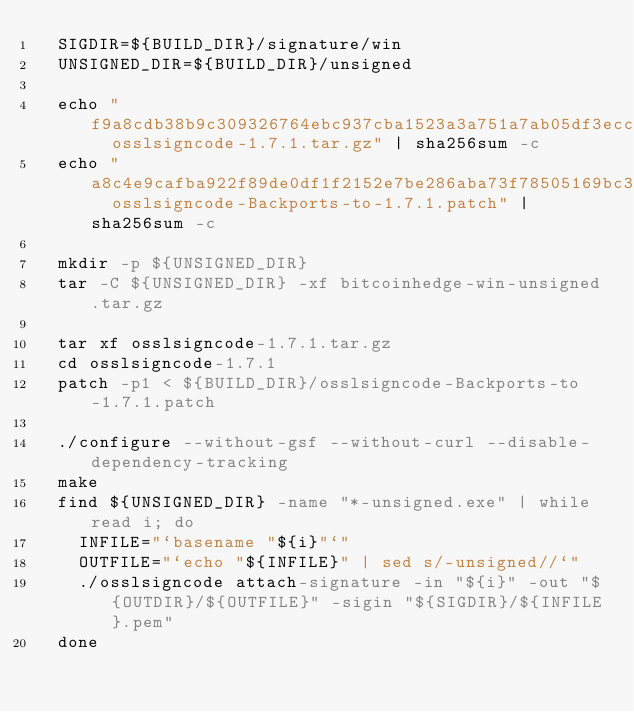<code> <loc_0><loc_0><loc_500><loc_500><_YAML_>  SIGDIR=${BUILD_DIR}/signature/win
  UNSIGNED_DIR=${BUILD_DIR}/unsigned

  echo "f9a8cdb38b9c309326764ebc937cba1523a3a751a7ab05df3ecc99d18ae466c9  osslsigncode-1.7.1.tar.gz" | sha256sum -c
  echo "a8c4e9cafba922f89de0df1f2152e7be286aba73f78505169bc351a7938dd911  osslsigncode-Backports-to-1.7.1.patch" | sha256sum -c

  mkdir -p ${UNSIGNED_DIR}
  tar -C ${UNSIGNED_DIR} -xf bitcoinhedge-win-unsigned.tar.gz

  tar xf osslsigncode-1.7.1.tar.gz
  cd osslsigncode-1.7.1
  patch -p1 < ${BUILD_DIR}/osslsigncode-Backports-to-1.7.1.patch

  ./configure --without-gsf --without-curl --disable-dependency-tracking
  make
  find ${UNSIGNED_DIR} -name "*-unsigned.exe" | while read i; do
    INFILE="`basename "${i}"`"
    OUTFILE="`echo "${INFILE}" | sed s/-unsigned//`"
    ./osslsigncode attach-signature -in "${i}" -out "${OUTDIR}/${OUTFILE}" -sigin "${SIGDIR}/${INFILE}.pem"
  done
</code> 